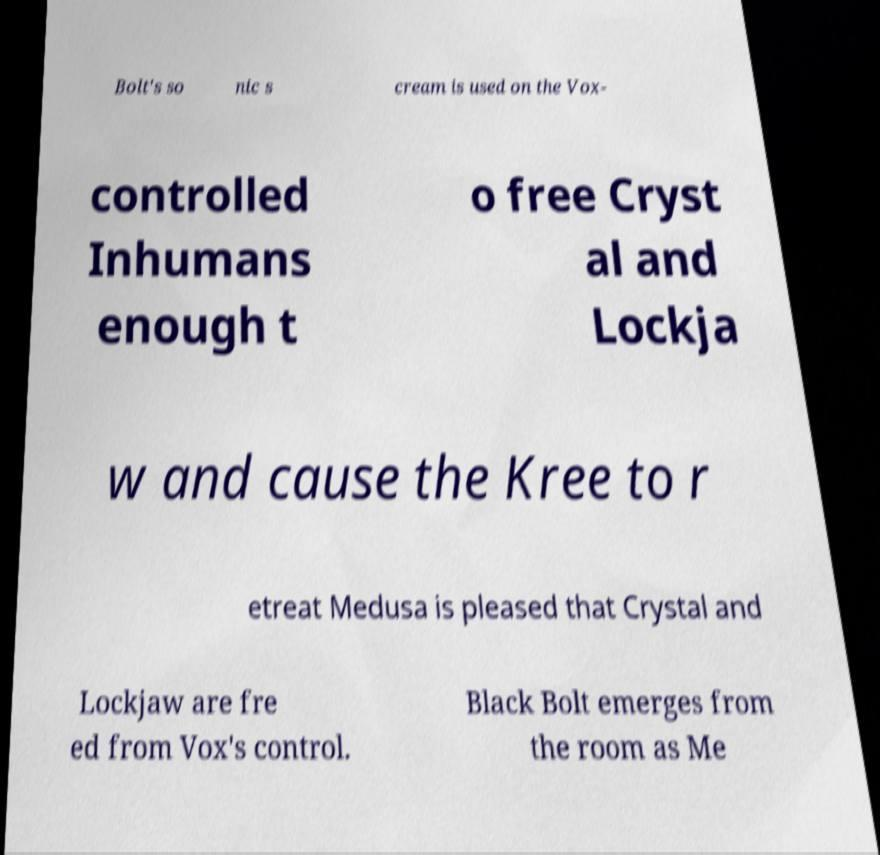Please identify and transcribe the text found in this image. Bolt's so nic s cream is used on the Vox- controlled Inhumans enough t o free Cryst al and Lockja w and cause the Kree to r etreat Medusa is pleased that Crystal and Lockjaw are fre ed from Vox's control. Black Bolt emerges from the room as Me 